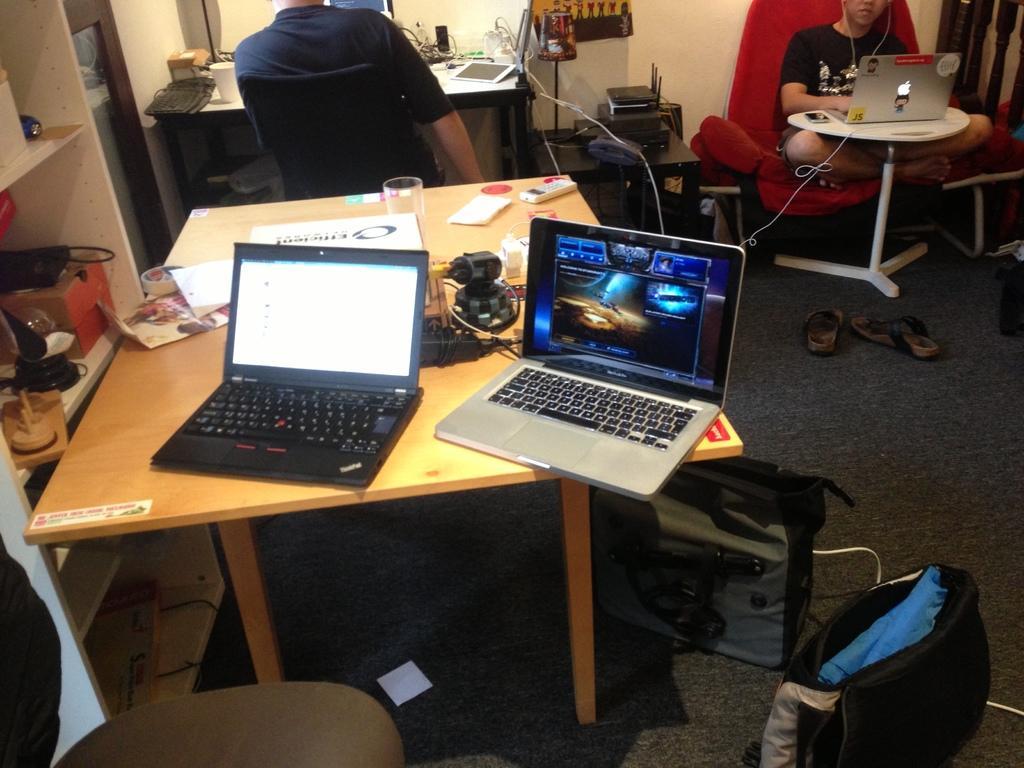In one or two sentences, can you explain what this image depicts? In this image on the left side there is one table on the table there are two laptops, glass, papers, are there. On the top there is a wall and on the right corner there is a red chair, on the chair there is one person who is sitting in front of him there is a laptop and on the left side there is a table and one chair on that chair there is one person who is sitting. 